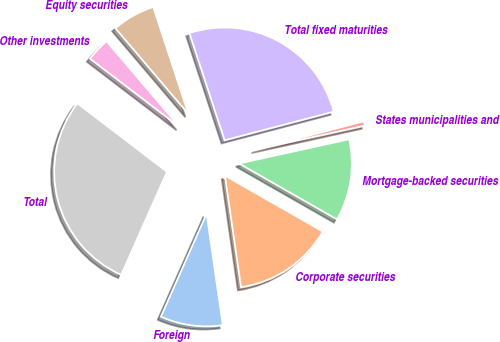Convert chart. <chart><loc_0><loc_0><loc_500><loc_500><pie_chart><fcel>Foreign<fcel>Corporate securities<fcel>Mortgage-backed securities<fcel>States municipalities and<fcel>Total fixed maturities<fcel>Equity securities<fcel>Other investments<fcel>Total<nl><fcel>8.93%<fcel>14.46%<fcel>11.7%<fcel>0.64%<fcel>25.97%<fcel>6.17%<fcel>3.4%<fcel>28.73%<nl></chart> 